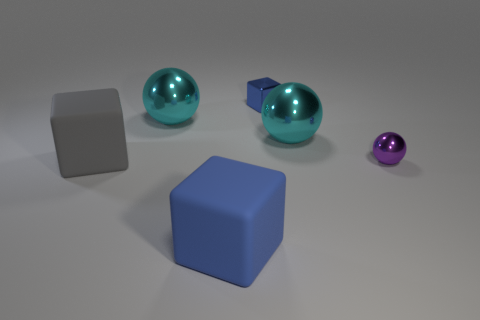There is a purple object that is the same size as the blue shiny cube; what is its shape?
Provide a short and direct response. Sphere. How many objects are on the left side of the purple thing and to the right of the large gray thing?
Ensure brevity in your answer.  4. Is the number of matte blocks that are in front of the tiny purple metal thing less than the number of gray things?
Keep it short and to the point. No. Are there any other objects of the same size as the gray thing?
Your answer should be compact. Yes. What is the color of the small sphere that is made of the same material as the tiny blue object?
Offer a very short reply. Purple. What number of cyan spheres are in front of the big metal ball to the left of the blue rubber thing?
Provide a succinct answer. 1. There is a object that is both on the right side of the tiny blue thing and behind the tiny purple ball; what material is it?
Provide a succinct answer. Metal. There is a tiny metal thing behind the small metal ball; does it have the same shape as the large blue matte object?
Keep it short and to the point. Yes. Are there fewer objects than cubes?
Your answer should be very brief. No. What number of shiny objects have the same color as the tiny shiny sphere?
Offer a terse response. 0. 